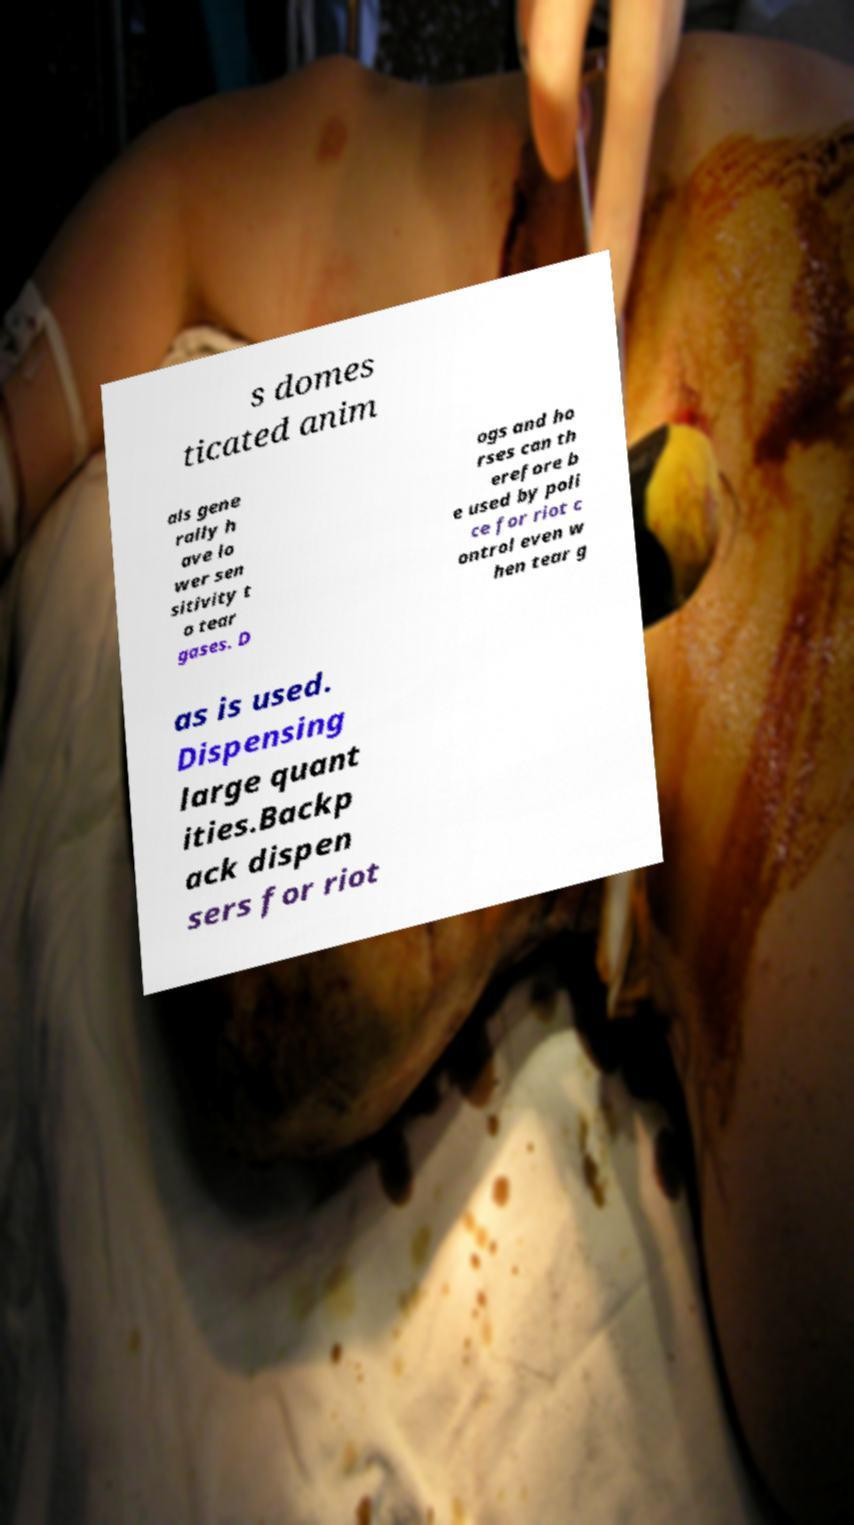Could you extract and type out the text from this image? s domes ticated anim als gene rally h ave lo wer sen sitivity t o tear gases. D ogs and ho rses can th erefore b e used by poli ce for riot c ontrol even w hen tear g as is used. Dispensing large quant ities.Backp ack dispen sers for riot 